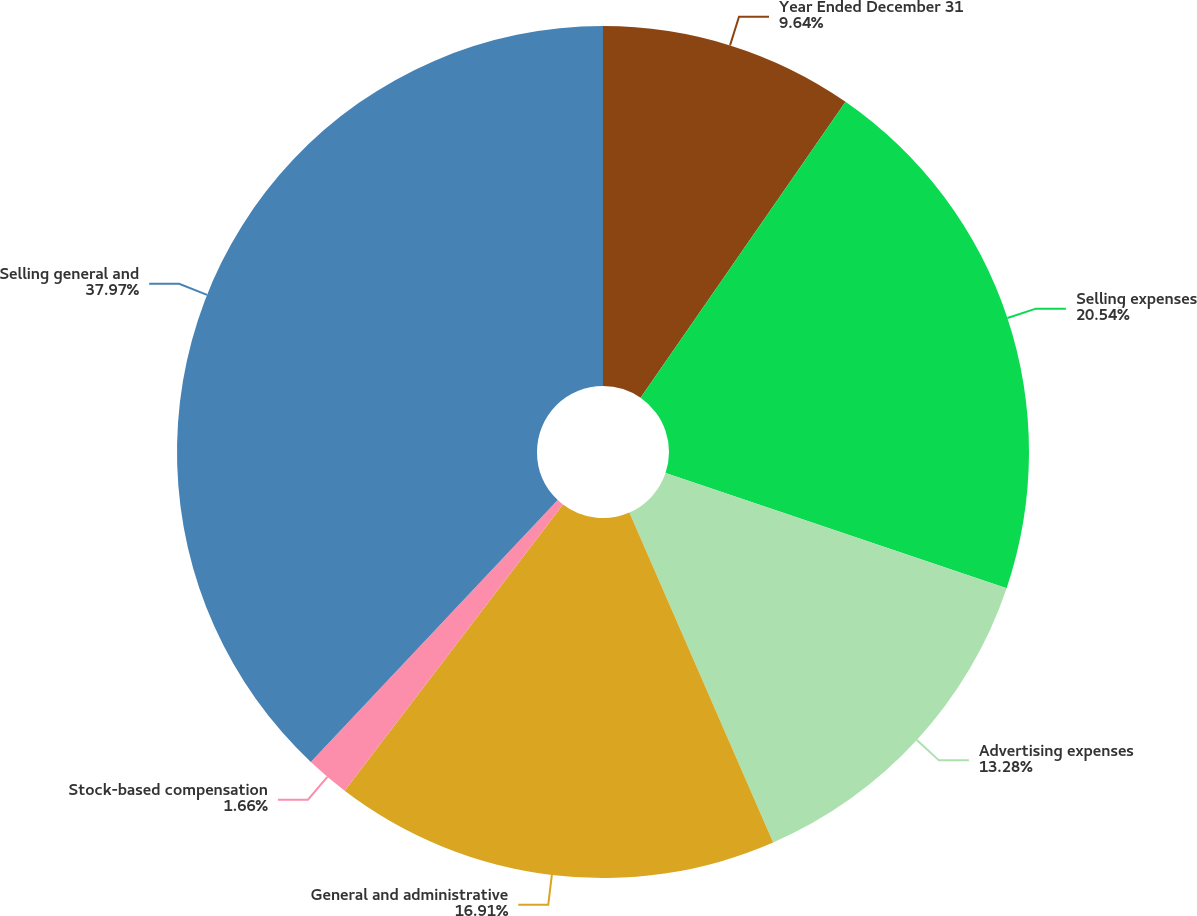Convert chart to OTSL. <chart><loc_0><loc_0><loc_500><loc_500><pie_chart><fcel>Year Ended December 31<fcel>Selling expenses<fcel>Advertising expenses<fcel>General and administrative<fcel>Stock-based compensation<fcel>Selling general and<nl><fcel>9.64%<fcel>20.54%<fcel>13.28%<fcel>16.91%<fcel>1.66%<fcel>37.97%<nl></chart> 